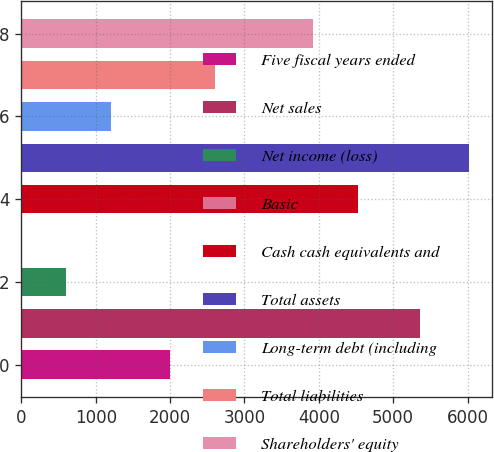Convert chart. <chart><loc_0><loc_0><loc_500><loc_500><bar_chart><fcel>Five fiscal years ended<fcel>Net sales<fcel>Net income (loss)<fcel>Basic<fcel>Cash cash equivalents and<fcel>Total assets<fcel>Long-term debt (including<fcel>Total liabilities<fcel>Shareholders' equity<nl><fcel>2001<fcel>5363<fcel>602.16<fcel>0.07<fcel>4522.09<fcel>6021<fcel>1204.25<fcel>2603.09<fcel>3920<nl></chart> 